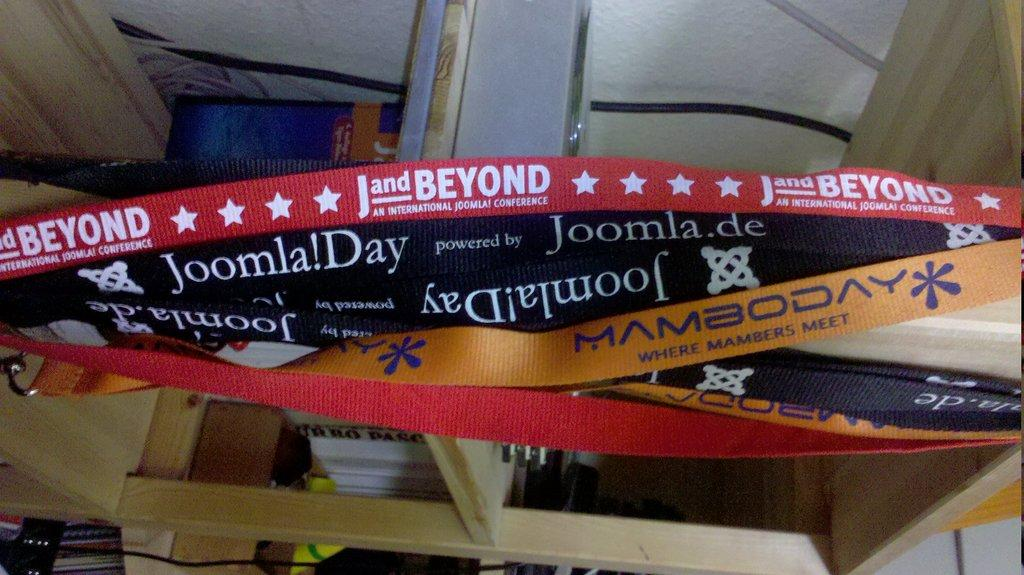<image>
Share a concise interpretation of the image provided. J and Beyond an international Joomla conference band. 